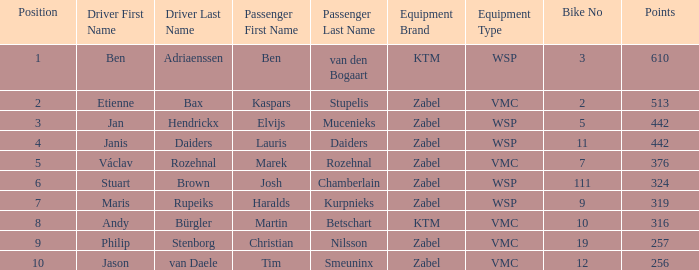What is the Equipment that has a Points littler than 442, and a Position of 9? Zabel-VMC. 